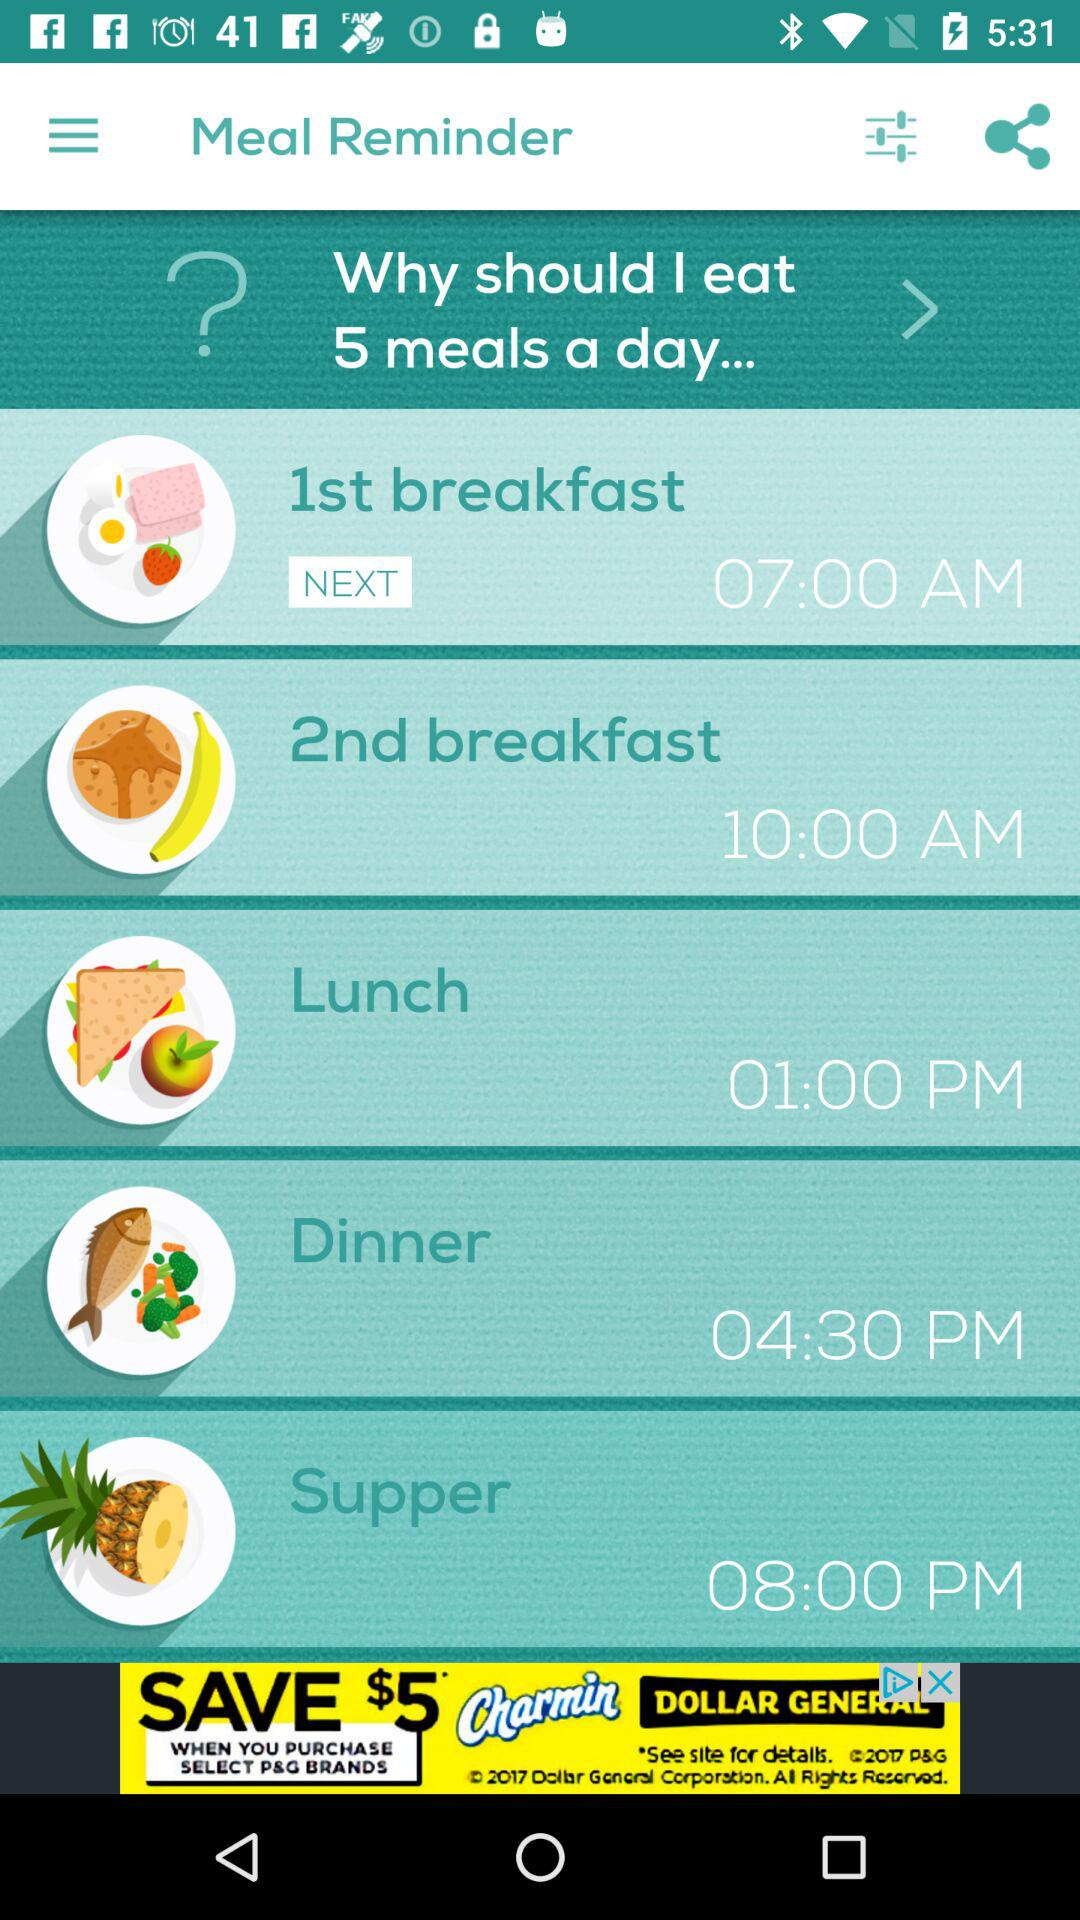What is the 1st breakfast time? The 1st breakfast time is 07:00 AM. 